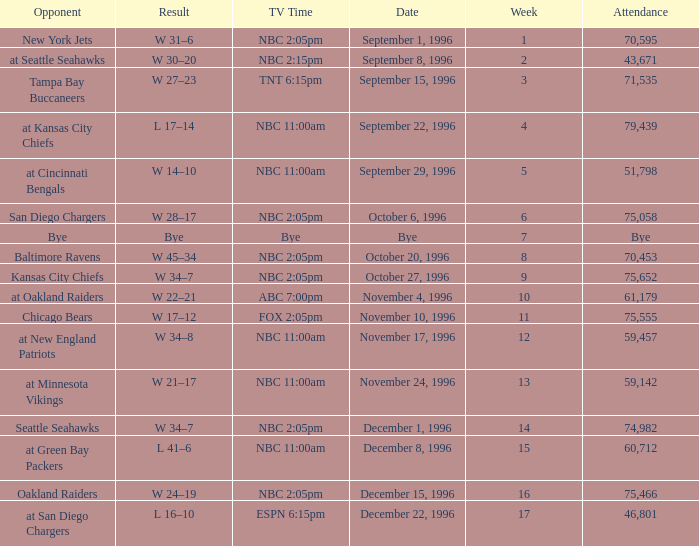Could you help me parse every detail presented in this table? {'header': ['Opponent', 'Result', 'TV Time', 'Date', 'Week', 'Attendance'], 'rows': [['New York Jets', 'W 31–6', 'NBC 2:05pm', 'September 1, 1996', '1', '70,595'], ['at Seattle Seahawks', 'W 30–20', 'NBC 2:15pm', 'September 8, 1996', '2', '43,671'], ['Tampa Bay Buccaneers', 'W 27–23', 'TNT 6:15pm', 'September 15, 1996', '3', '71,535'], ['at Kansas City Chiefs', 'L 17–14', 'NBC 11:00am', 'September 22, 1996', '4', '79,439'], ['at Cincinnati Bengals', 'W 14–10', 'NBC 11:00am', 'September 29, 1996', '5', '51,798'], ['San Diego Chargers', 'W 28–17', 'NBC 2:05pm', 'October 6, 1996', '6', '75,058'], ['Bye', 'Bye', 'Bye', 'Bye', '7', 'Bye'], ['Baltimore Ravens', 'W 45–34', 'NBC 2:05pm', 'October 20, 1996', '8', '70,453'], ['Kansas City Chiefs', 'W 34–7', 'NBC 2:05pm', 'October 27, 1996', '9', '75,652'], ['at Oakland Raiders', 'W 22–21', 'ABC 7:00pm', 'November 4, 1996', '10', '61,179'], ['Chicago Bears', 'W 17–12', 'FOX 2:05pm', 'November 10, 1996', '11', '75,555'], ['at New England Patriots', 'W 34–8', 'NBC 11:00am', 'November 17, 1996', '12', '59,457'], ['at Minnesota Vikings', 'W 21–17', 'NBC 11:00am', 'November 24, 1996', '13', '59,142'], ['Seattle Seahawks', 'W 34–7', 'NBC 2:05pm', 'December 1, 1996', '14', '74,982'], ['at Green Bay Packers', 'L 41–6', 'NBC 11:00am', 'December 8, 1996', '15', '60,712'], ['Oakland Raiders', 'W 24–19', 'NBC 2:05pm', 'December 15, 1996', '16', '75,466'], ['at San Diego Chargers', 'L 16–10', 'ESPN 6:15pm', 'December 22, 1996', '17', '46,801']]} WHAT IS THE RESULT WHEN THE OPPONENT WAS CHICAGO BEARS? W 17–12. 